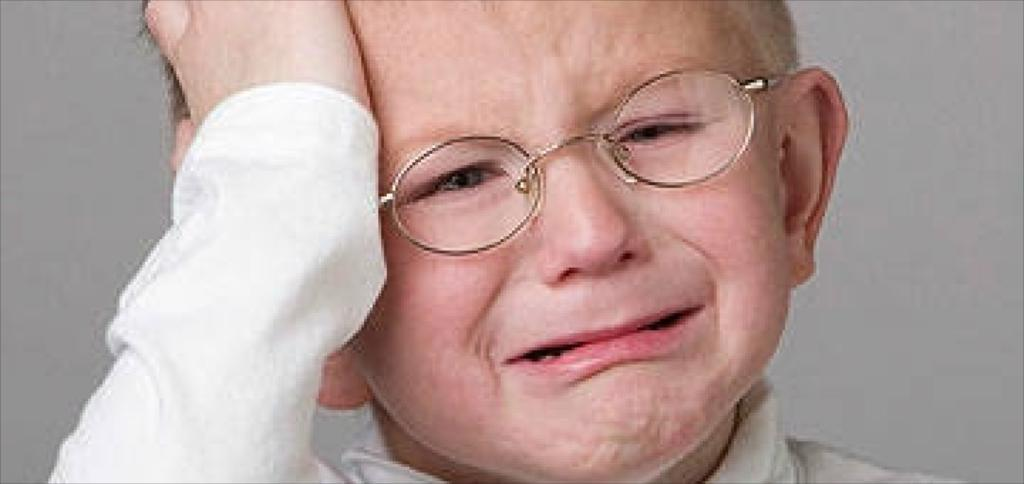What is the main subject of the image? The main subject of the image is a kid. Can you describe the appearance of the kid? The kid is wearing spectacles. What is the emotional state of the kid in the image? The kid is crying. What type of expansion can be seen in the image? There is no expansion present in the image; it features a kid wearing spectacles and crying. Can you tell me how much eggnog the kid is holding in the image? There is no eggnog present in the image. 